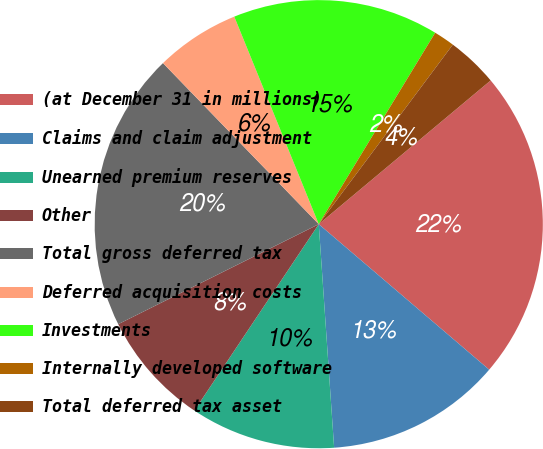Convert chart. <chart><loc_0><loc_0><loc_500><loc_500><pie_chart><fcel>(at December 31 in millions)<fcel>Claims and claim adjustment<fcel>Unearned premium reserves<fcel>Other<fcel>Total gross deferred tax<fcel>Deferred acquisition costs<fcel>Investments<fcel>Internally developed software<fcel>Total deferred tax asset<nl><fcel>22.33%<fcel>12.66%<fcel>10.46%<fcel>8.27%<fcel>20.13%<fcel>6.08%<fcel>14.85%<fcel>1.51%<fcel>3.71%<nl></chart> 